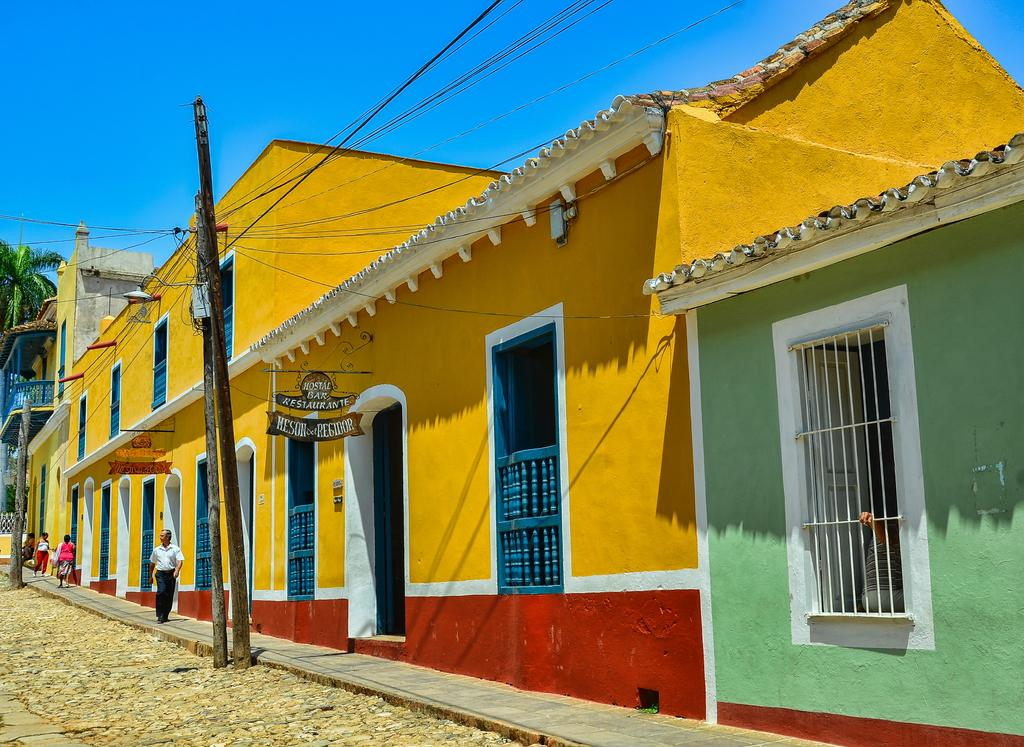What can be seen in the image? There are persons standing, buildings, poles, cables, boards, a tree, and the sky is visible in the background. Can you describe the people in the image? The provided facts do not give specific details about the people, so we cannot describe them. What are the poles and cables used for in the image? The poles and cables are likely used for supporting and transmitting electrical or communication lines. What type of structure is represented by the boards in the image? The provided facts do not give specific details about the boards, so we cannot determine their purpose or type. What type of doctor is depicted on the boards in the image? There is no doctor depicted on the boards in the image; they are simply boards. What type of religion is practiced by the persons standing in the image? There is no information about the religion of the persons standing in the image, so we cannot determine their religious beliefs. 